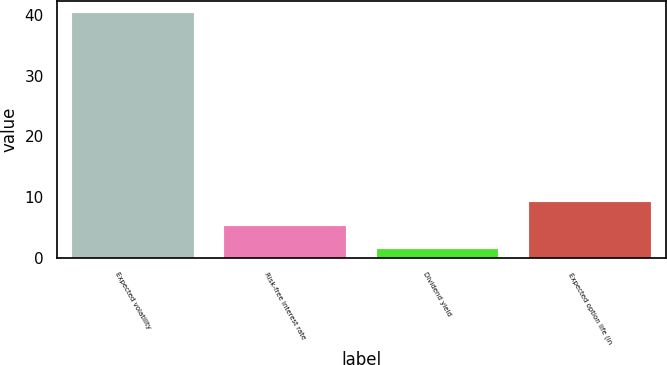Convert chart. <chart><loc_0><loc_0><loc_500><loc_500><bar_chart><fcel>Expected volatility<fcel>Risk-free interest rate<fcel>Dividend yield<fcel>Expected option life (in<nl><fcel>40.31<fcel>5.33<fcel>1.44<fcel>9.22<nl></chart> 